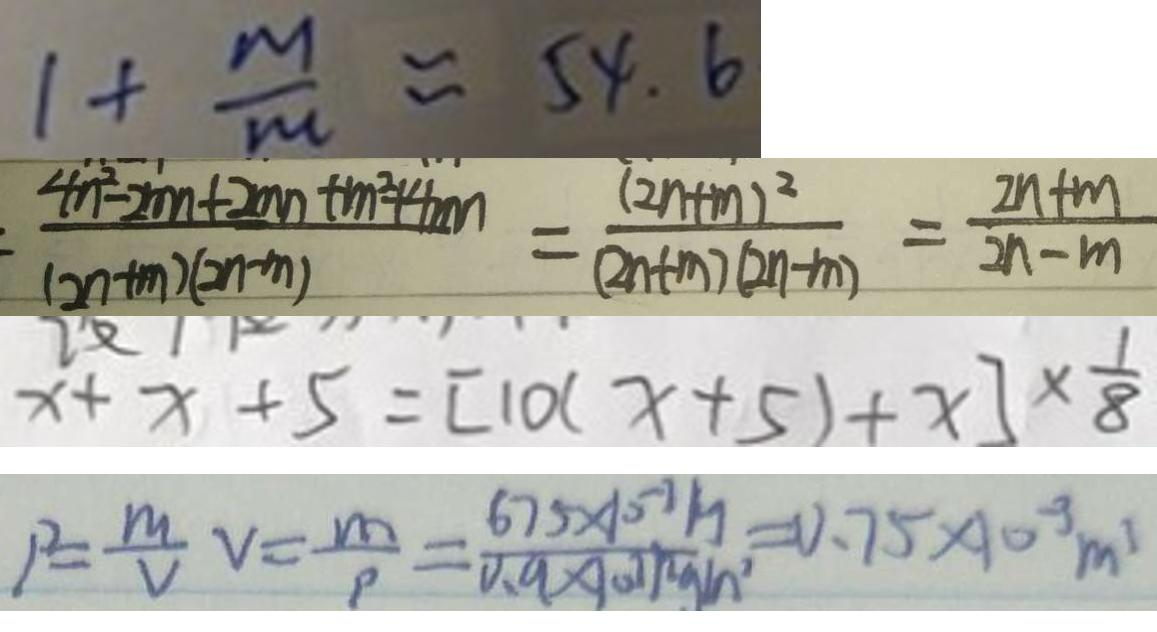Convert formula to latex. <formula><loc_0><loc_0><loc_500><loc_500>1 + \frac { m } { m } \approx 5 4 . 6 
 \frac { 4 n ^ { 2 } - 2 m n + 2 m n + m ^ { 2 } + 4 m n } { ( 2 n + m ) ( 2 n - m ) } = \frac { ( 2 n + m ) ^ { 2 } } { ( 2 n + m ) ( 2 n - m ) } = \frac { 2 n + m } { 2 n - m } 
 x + x + 5 = [ 1 0 ( x + 5 ) + x ] \times \frac { 1 } { 8 } 
 1 ^ { 2 } = \frac { m } { V } v = \frac { m } { p } = \frac { 6 7 5 \times 1 0 ^ { - 3 } m } { 0 . 9 \times 1 0 ^ { - 3 } m ^ { 3 } g / m ^ { 3 } } = 0 . 7 5 \times 1 0 ^ { - 3 } m ^ { 3 }</formula> 